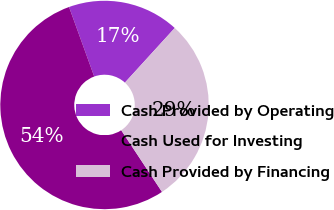Convert chart. <chart><loc_0><loc_0><loc_500><loc_500><pie_chart><fcel>Cash Provided by Operating<fcel>Cash Used for Investing<fcel>Cash Provided by Financing<nl><fcel>17.3%<fcel>53.77%<fcel>28.93%<nl></chart> 